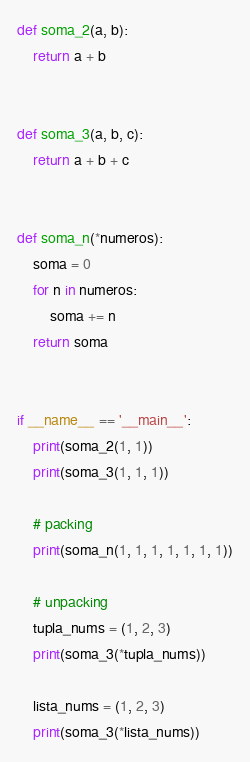Convert code to text. <code><loc_0><loc_0><loc_500><loc_500><_Python_>def soma_2(a, b):
    return a + b


def soma_3(a, b, c):
    return a + b + c


def soma_n(*numeros):
    soma = 0
    for n in numeros:
        soma += n
    return soma


if __name__ == '__main__':
    print(soma_2(1, 1))
    print(soma_3(1, 1, 1))

    # packing
    print(soma_n(1, 1, 1, 1, 1, 1, 1))

    # unpacking
    tupla_nums = (1, 2, 3)
    print(soma_3(*tupla_nums))

    lista_nums = (1, 2, 3)
    print(soma_3(*lista_nums))
</code> 